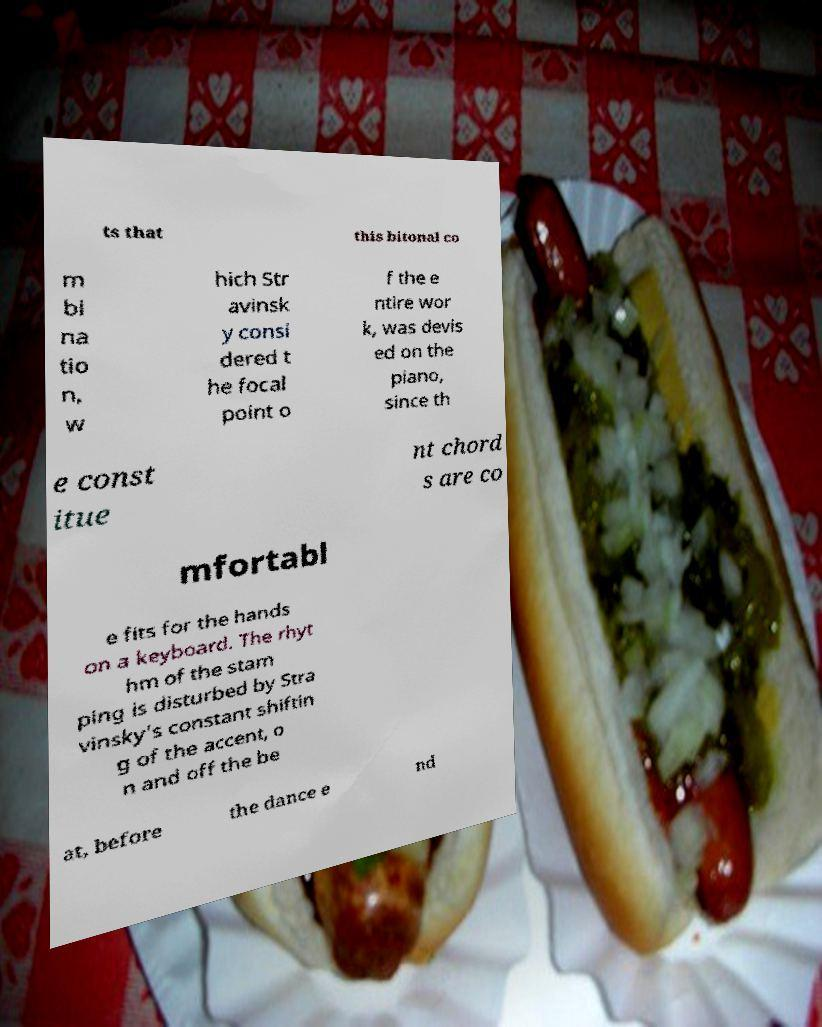I need the written content from this picture converted into text. Can you do that? ts that this bitonal co m bi na tio n, w hich Str avinsk y consi dered t he focal point o f the e ntire wor k, was devis ed on the piano, since th e const itue nt chord s are co mfortabl e fits for the hands on a keyboard. The rhyt hm of the stam ping is disturbed by Stra vinsky's constant shiftin g of the accent, o n and off the be at, before the dance e nd 